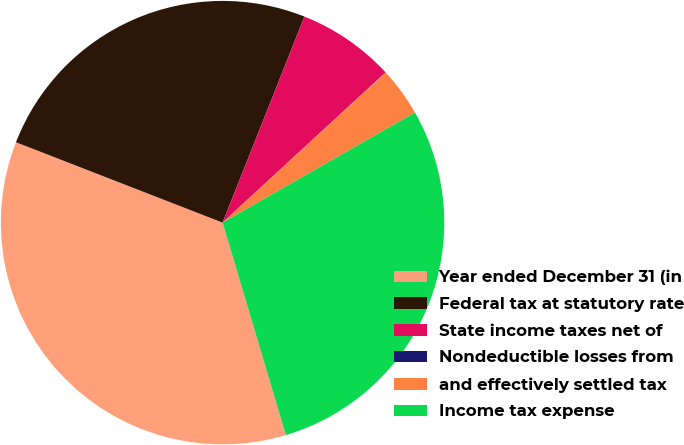<chart> <loc_0><loc_0><loc_500><loc_500><pie_chart><fcel>Year ended December 31 (in<fcel>Federal tax at statutory rate<fcel>State income taxes net of<fcel>Nondeductible losses from<fcel>and effectively settled tax<fcel>Income tax expense<nl><fcel>35.52%<fcel>25.12%<fcel>7.12%<fcel>0.02%<fcel>3.57%<fcel>28.67%<nl></chart> 